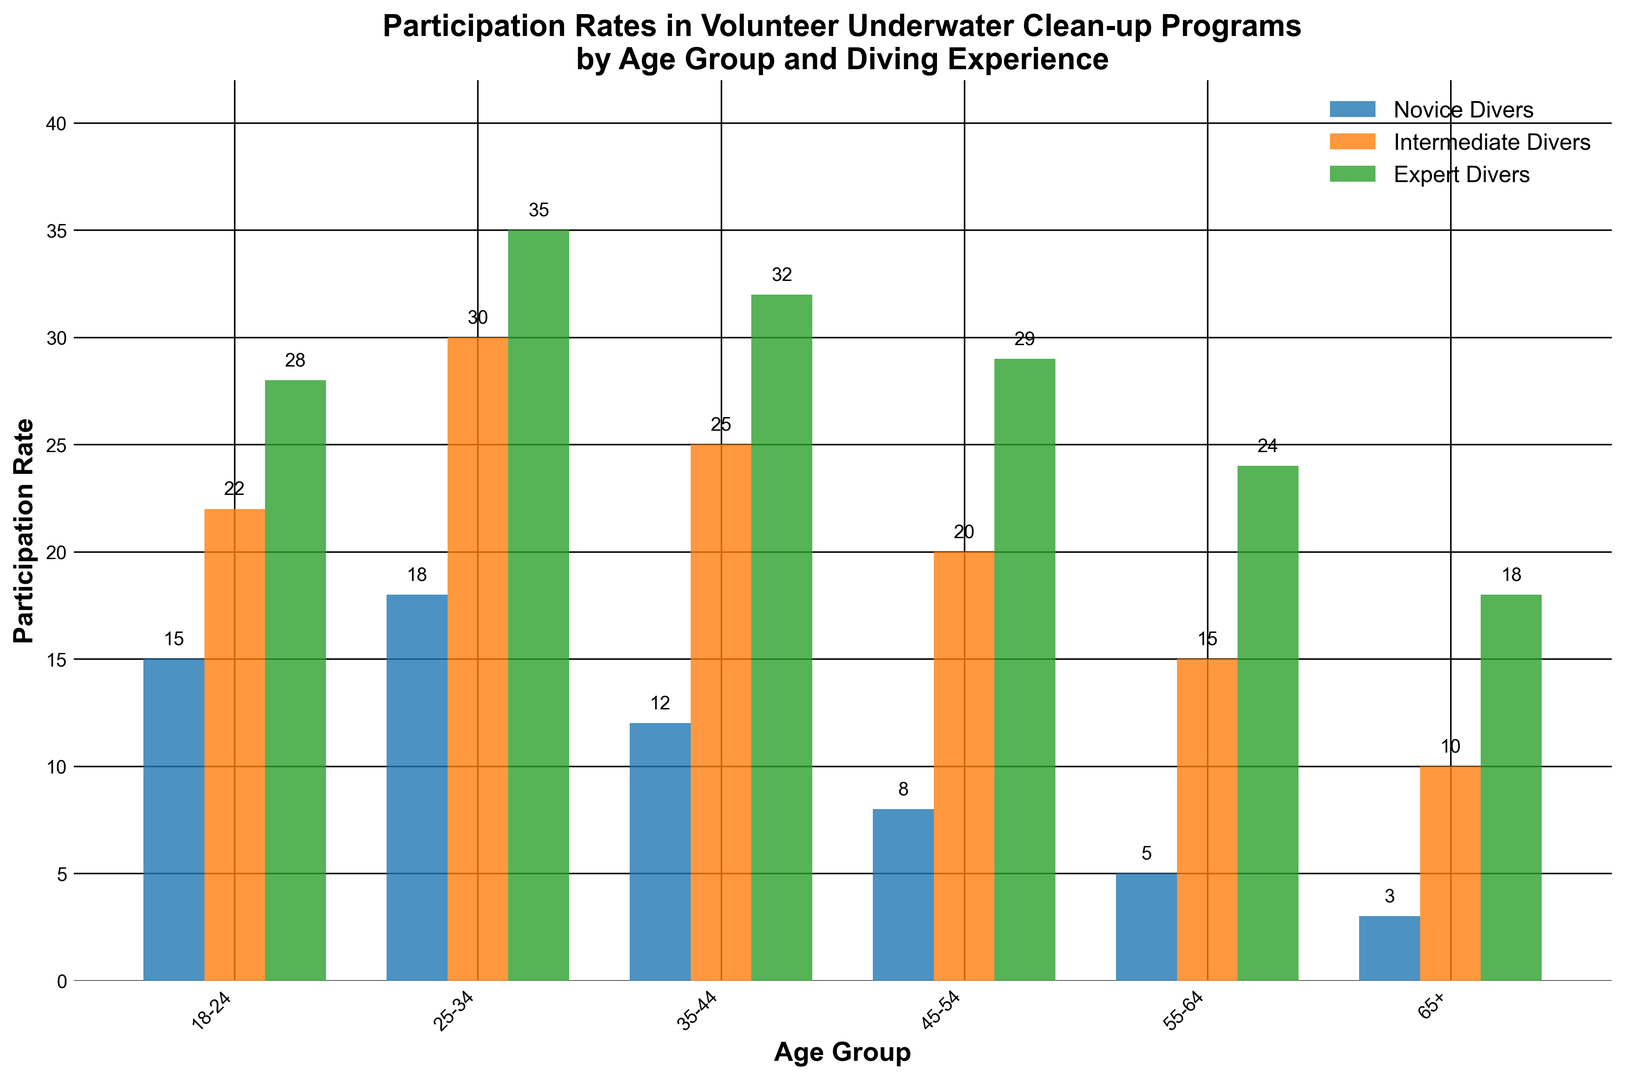Which age group has the highest participation rate among novice divers? By comparing the height of the blue bars across all age groups, the age group 25-34 has the highest participation rate with a value of 18.
Answer: 25-34 What is the difference in participation rates between the novice and expert divers in the 35-44 age group? The participation rate for novice divers is 12 and for expert divers is 32. The difference is calculated as 32 - 12 = 20.
Answer: 20 Which group of divers shows the most consistent participation rates across different age groups? By examining the heights of the bars for each diving experience across age groups, expert divers (green bars) appear to show the most consistent heights compared to novice and intermediate divers, indicating more consistency.
Answer: Expert divers What is the total participation rate for the intermediate divers across all age groups? Sum the values for intermediate divers across all age groups: 22 + 30 + 25 + 20 + 15 + 10 = 122.
Answer: 122 In the 18-24 age group, how does the participation rate of intermediate divers compare to that of expert divers? The participation rate for intermediate divers is 22 and for expert divers is 28. Comparing the two, intermediate divers have a lower participation rate than expert divers in this age group.
Answer: Lower Which age group has the lowest participation rate among all divers? By examining the bars for all age groups, the 65+ age group has the lowest participation rates with values of 3 (novice), 10 (intermediate), and 18 (expert).
Answer: 65+ How much higher is the participation rate of expert divers than novice divers in the 45-54 age group? The participation rate for expert divers is 29 and for novice divers is 8. The difference is calculated as 29 - 8 = 21.
Answer: 21 What is the average participation rate in the 55-64 age group across all types of divers? Sum the values for all divers in the 55-64 age group: 5 + 15 + 24 = 44. The average is 44 / 3 ≈ 14.67.
Answer: 14.67 Is the participation rate of novice divers more than half of the participation rate of intermediate divers in the 25-34 age group? The participation rate for novice divers is 18 and for intermediate divers is 30. Half of 30 is 15. Since 18 > 15, the participation rate of novice divers is more than half of the intermediate divers.
Answer: Yes 